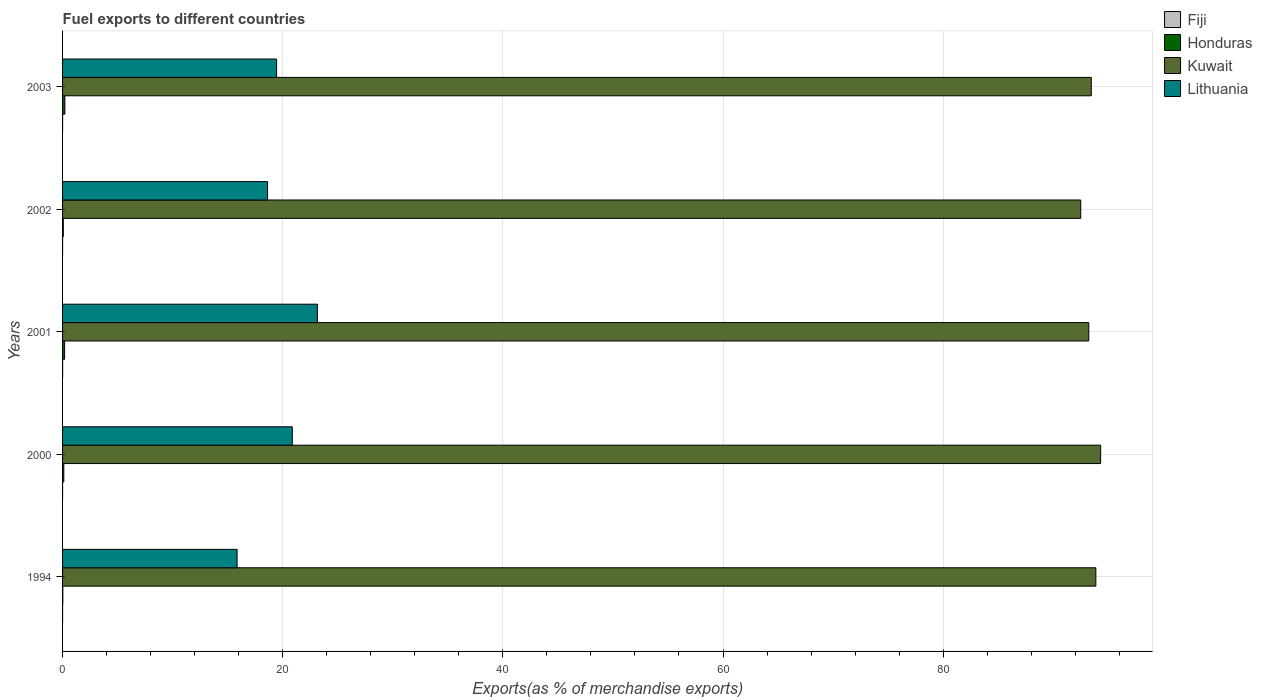How many different coloured bars are there?
Give a very brief answer. 4. Are the number of bars per tick equal to the number of legend labels?
Provide a succinct answer. Yes. Are the number of bars on each tick of the Y-axis equal?
Provide a succinct answer. Yes. How many bars are there on the 5th tick from the top?
Offer a terse response. 4. What is the percentage of exports to different countries in Kuwait in 2003?
Ensure brevity in your answer.  93.46. Across all years, what is the maximum percentage of exports to different countries in Honduras?
Keep it short and to the point. 0.21. Across all years, what is the minimum percentage of exports to different countries in Honduras?
Your answer should be compact. 0.02. In which year was the percentage of exports to different countries in Lithuania maximum?
Provide a succinct answer. 2001. In which year was the percentage of exports to different countries in Honduras minimum?
Provide a succinct answer. 1994. What is the total percentage of exports to different countries in Kuwait in the graph?
Ensure brevity in your answer.  467.36. What is the difference between the percentage of exports to different countries in Lithuania in 1994 and that in 2003?
Give a very brief answer. -3.59. What is the difference between the percentage of exports to different countries in Lithuania in 2001 and the percentage of exports to different countries in Kuwait in 2002?
Your answer should be very brief. -69.35. What is the average percentage of exports to different countries in Honduras per year?
Provide a short and direct response. 0.12. In the year 2001, what is the difference between the percentage of exports to different countries in Fiji and percentage of exports to different countries in Honduras?
Make the answer very short. -0.18. What is the ratio of the percentage of exports to different countries in Fiji in 2002 to that in 2003?
Your answer should be very brief. 1.53. Is the percentage of exports to different countries in Honduras in 2000 less than that in 2001?
Offer a very short reply. Yes. What is the difference between the highest and the second highest percentage of exports to different countries in Kuwait?
Your answer should be very brief. 0.43. What is the difference between the highest and the lowest percentage of exports to different countries in Fiji?
Offer a very short reply. 0.01. What does the 4th bar from the top in 2002 represents?
Your response must be concise. Fiji. What does the 2nd bar from the bottom in 1994 represents?
Provide a succinct answer. Honduras. Are all the bars in the graph horizontal?
Your answer should be very brief. Yes. What is the difference between two consecutive major ticks on the X-axis?
Your answer should be compact. 20. Does the graph contain any zero values?
Ensure brevity in your answer.  No. Where does the legend appear in the graph?
Ensure brevity in your answer.  Top right. How are the legend labels stacked?
Ensure brevity in your answer.  Vertical. What is the title of the graph?
Your answer should be compact. Fuel exports to different countries. Does "Jordan" appear as one of the legend labels in the graph?
Make the answer very short. No. What is the label or title of the X-axis?
Your answer should be very brief. Exports(as % of merchandise exports). What is the label or title of the Y-axis?
Provide a short and direct response. Years. What is the Exports(as % of merchandise exports) of Fiji in 1994?
Make the answer very short. 0. What is the Exports(as % of merchandise exports) in Honduras in 1994?
Ensure brevity in your answer.  0.02. What is the Exports(as % of merchandise exports) in Kuwait in 1994?
Make the answer very short. 93.87. What is the Exports(as % of merchandise exports) of Lithuania in 1994?
Offer a terse response. 15.86. What is the Exports(as % of merchandise exports) in Fiji in 2000?
Make the answer very short. 0. What is the Exports(as % of merchandise exports) in Honduras in 2000?
Keep it short and to the point. 0.11. What is the Exports(as % of merchandise exports) of Kuwait in 2000?
Ensure brevity in your answer.  94.31. What is the Exports(as % of merchandise exports) in Lithuania in 2000?
Keep it short and to the point. 20.87. What is the Exports(as % of merchandise exports) in Fiji in 2001?
Your response must be concise. 0.01. What is the Exports(as % of merchandise exports) of Honduras in 2001?
Your response must be concise. 0.18. What is the Exports(as % of merchandise exports) in Kuwait in 2001?
Offer a terse response. 93.23. What is the Exports(as % of merchandise exports) of Lithuania in 2001?
Offer a very short reply. 23.15. What is the Exports(as % of merchandise exports) of Fiji in 2002?
Give a very brief answer. 0. What is the Exports(as % of merchandise exports) in Honduras in 2002?
Provide a short and direct response. 0.07. What is the Exports(as % of merchandise exports) of Kuwait in 2002?
Provide a succinct answer. 92.5. What is the Exports(as % of merchandise exports) in Lithuania in 2002?
Your response must be concise. 18.62. What is the Exports(as % of merchandise exports) of Fiji in 2003?
Give a very brief answer. 0. What is the Exports(as % of merchandise exports) in Honduras in 2003?
Give a very brief answer. 0.21. What is the Exports(as % of merchandise exports) of Kuwait in 2003?
Ensure brevity in your answer.  93.46. What is the Exports(as % of merchandise exports) of Lithuania in 2003?
Make the answer very short. 19.44. Across all years, what is the maximum Exports(as % of merchandise exports) in Fiji?
Provide a succinct answer. 0.01. Across all years, what is the maximum Exports(as % of merchandise exports) in Honduras?
Your answer should be very brief. 0.21. Across all years, what is the maximum Exports(as % of merchandise exports) of Kuwait?
Ensure brevity in your answer.  94.31. Across all years, what is the maximum Exports(as % of merchandise exports) in Lithuania?
Offer a very short reply. 23.15. Across all years, what is the minimum Exports(as % of merchandise exports) of Fiji?
Give a very brief answer. 0. Across all years, what is the minimum Exports(as % of merchandise exports) of Honduras?
Offer a terse response. 0.02. Across all years, what is the minimum Exports(as % of merchandise exports) in Kuwait?
Give a very brief answer. 92.5. Across all years, what is the minimum Exports(as % of merchandise exports) in Lithuania?
Make the answer very short. 15.86. What is the total Exports(as % of merchandise exports) of Fiji in the graph?
Offer a very short reply. 0.01. What is the total Exports(as % of merchandise exports) in Honduras in the graph?
Make the answer very short. 0.6. What is the total Exports(as % of merchandise exports) of Kuwait in the graph?
Your response must be concise. 467.36. What is the total Exports(as % of merchandise exports) of Lithuania in the graph?
Ensure brevity in your answer.  97.95. What is the difference between the Exports(as % of merchandise exports) in Fiji in 1994 and that in 2000?
Offer a very short reply. 0. What is the difference between the Exports(as % of merchandise exports) of Honduras in 1994 and that in 2000?
Keep it short and to the point. -0.09. What is the difference between the Exports(as % of merchandise exports) in Kuwait in 1994 and that in 2000?
Ensure brevity in your answer.  -0.43. What is the difference between the Exports(as % of merchandise exports) of Lithuania in 1994 and that in 2000?
Your answer should be very brief. -5.02. What is the difference between the Exports(as % of merchandise exports) in Fiji in 1994 and that in 2001?
Offer a very short reply. -0. What is the difference between the Exports(as % of merchandise exports) of Honduras in 1994 and that in 2001?
Your answer should be compact. -0.16. What is the difference between the Exports(as % of merchandise exports) in Kuwait in 1994 and that in 2001?
Make the answer very short. 0.64. What is the difference between the Exports(as % of merchandise exports) of Lithuania in 1994 and that in 2001?
Your answer should be very brief. -7.3. What is the difference between the Exports(as % of merchandise exports) in Fiji in 1994 and that in 2002?
Your answer should be compact. 0. What is the difference between the Exports(as % of merchandise exports) in Honduras in 1994 and that in 2002?
Keep it short and to the point. -0.05. What is the difference between the Exports(as % of merchandise exports) in Kuwait in 1994 and that in 2002?
Your answer should be compact. 1.37. What is the difference between the Exports(as % of merchandise exports) in Lithuania in 1994 and that in 2002?
Your response must be concise. -2.77. What is the difference between the Exports(as % of merchandise exports) of Fiji in 1994 and that in 2003?
Your answer should be very brief. 0. What is the difference between the Exports(as % of merchandise exports) in Honduras in 1994 and that in 2003?
Provide a short and direct response. -0.19. What is the difference between the Exports(as % of merchandise exports) in Kuwait in 1994 and that in 2003?
Your answer should be very brief. 0.41. What is the difference between the Exports(as % of merchandise exports) in Lithuania in 1994 and that in 2003?
Provide a short and direct response. -3.59. What is the difference between the Exports(as % of merchandise exports) of Fiji in 2000 and that in 2001?
Provide a succinct answer. -0.01. What is the difference between the Exports(as % of merchandise exports) of Honduras in 2000 and that in 2001?
Provide a succinct answer. -0.07. What is the difference between the Exports(as % of merchandise exports) in Kuwait in 2000 and that in 2001?
Your answer should be very brief. 1.08. What is the difference between the Exports(as % of merchandise exports) of Lithuania in 2000 and that in 2001?
Make the answer very short. -2.28. What is the difference between the Exports(as % of merchandise exports) in Fiji in 2000 and that in 2002?
Offer a terse response. -0. What is the difference between the Exports(as % of merchandise exports) in Honduras in 2000 and that in 2002?
Offer a very short reply. 0.05. What is the difference between the Exports(as % of merchandise exports) in Kuwait in 2000 and that in 2002?
Ensure brevity in your answer.  1.81. What is the difference between the Exports(as % of merchandise exports) in Lithuania in 2000 and that in 2002?
Your response must be concise. 2.25. What is the difference between the Exports(as % of merchandise exports) of Fiji in 2000 and that in 2003?
Your response must be concise. -0. What is the difference between the Exports(as % of merchandise exports) in Honduras in 2000 and that in 2003?
Make the answer very short. -0.1. What is the difference between the Exports(as % of merchandise exports) of Kuwait in 2000 and that in 2003?
Your response must be concise. 0.85. What is the difference between the Exports(as % of merchandise exports) in Lithuania in 2000 and that in 2003?
Provide a succinct answer. 1.43. What is the difference between the Exports(as % of merchandise exports) of Fiji in 2001 and that in 2002?
Provide a short and direct response. 0.01. What is the difference between the Exports(as % of merchandise exports) of Honduras in 2001 and that in 2002?
Give a very brief answer. 0.12. What is the difference between the Exports(as % of merchandise exports) in Kuwait in 2001 and that in 2002?
Your answer should be very brief. 0.73. What is the difference between the Exports(as % of merchandise exports) of Lithuania in 2001 and that in 2002?
Offer a very short reply. 4.53. What is the difference between the Exports(as % of merchandise exports) of Fiji in 2001 and that in 2003?
Your answer should be compact. 0.01. What is the difference between the Exports(as % of merchandise exports) of Honduras in 2001 and that in 2003?
Offer a terse response. -0.03. What is the difference between the Exports(as % of merchandise exports) in Kuwait in 2001 and that in 2003?
Give a very brief answer. -0.23. What is the difference between the Exports(as % of merchandise exports) of Lithuania in 2001 and that in 2003?
Keep it short and to the point. 3.71. What is the difference between the Exports(as % of merchandise exports) in Honduras in 2002 and that in 2003?
Your answer should be compact. -0.14. What is the difference between the Exports(as % of merchandise exports) of Kuwait in 2002 and that in 2003?
Keep it short and to the point. -0.96. What is the difference between the Exports(as % of merchandise exports) in Lithuania in 2002 and that in 2003?
Provide a short and direct response. -0.82. What is the difference between the Exports(as % of merchandise exports) of Fiji in 1994 and the Exports(as % of merchandise exports) of Honduras in 2000?
Give a very brief answer. -0.11. What is the difference between the Exports(as % of merchandise exports) in Fiji in 1994 and the Exports(as % of merchandise exports) in Kuwait in 2000?
Give a very brief answer. -94.3. What is the difference between the Exports(as % of merchandise exports) in Fiji in 1994 and the Exports(as % of merchandise exports) in Lithuania in 2000?
Give a very brief answer. -20.87. What is the difference between the Exports(as % of merchandise exports) in Honduras in 1994 and the Exports(as % of merchandise exports) in Kuwait in 2000?
Provide a succinct answer. -94.28. What is the difference between the Exports(as % of merchandise exports) in Honduras in 1994 and the Exports(as % of merchandise exports) in Lithuania in 2000?
Provide a short and direct response. -20.85. What is the difference between the Exports(as % of merchandise exports) in Kuwait in 1994 and the Exports(as % of merchandise exports) in Lithuania in 2000?
Offer a terse response. 73. What is the difference between the Exports(as % of merchandise exports) of Fiji in 1994 and the Exports(as % of merchandise exports) of Honduras in 2001?
Provide a succinct answer. -0.18. What is the difference between the Exports(as % of merchandise exports) of Fiji in 1994 and the Exports(as % of merchandise exports) of Kuwait in 2001?
Your answer should be very brief. -93.23. What is the difference between the Exports(as % of merchandise exports) of Fiji in 1994 and the Exports(as % of merchandise exports) of Lithuania in 2001?
Your response must be concise. -23.15. What is the difference between the Exports(as % of merchandise exports) in Honduras in 1994 and the Exports(as % of merchandise exports) in Kuwait in 2001?
Provide a short and direct response. -93.21. What is the difference between the Exports(as % of merchandise exports) of Honduras in 1994 and the Exports(as % of merchandise exports) of Lithuania in 2001?
Your answer should be very brief. -23.13. What is the difference between the Exports(as % of merchandise exports) in Kuwait in 1994 and the Exports(as % of merchandise exports) in Lithuania in 2001?
Your answer should be compact. 70.72. What is the difference between the Exports(as % of merchandise exports) of Fiji in 1994 and the Exports(as % of merchandise exports) of Honduras in 2002?
Provide a succinct answer. -0.07. What is the difference between the Exports(as % of merchandise exports) in Fiji in 1994 and the Exports(as % of merchandise exports) in Kuwait in 2002?
Make the answer very short. -92.5. What is the difference between the Exports(as % of merchandise exports) in Fiji in 1994 and the Exports(as % of merchandise exports) in Lithuania in 2002?
Provide a succinct answer. -18.62. What is the difference between the Exports(as % of merchandise exports) of Honduras in 1994 and the Exports(as % of merchandise exports) of Kuwait in 2002?
Provide a succinct answer. -92.48. What is the difference between the Exports(as % of merchandise exports) in Honduras in 1994 and the Exports(as % of merchandise exports) in Lithuania in 2002?
Provide a succinct answer. -18.6. What is the difference between the Exports(as % of merchandise exports) in Kuwait in 1994 and the Exports(as % of merchandise exports) in Lithuania in 2002?
Your answer should be very brief. 75.25. What is the difference between the Exports(as % of merchandise exports) in Fiji in 1994 and the Exports(as % of merchandise exports) in Honduras in 2003?
Provide a succinct answer. -0.21. What is the difference between the Exports(as % of merchandise exports) in Fiji in 1994 and the Exports(as % of merchandise exports) in Kuwait in 2003?
Ensure brevity in your answer.  -93.46. What is the difference between the Exports(as % of merchandise exports) of Fiji in 1994 and the Exports(as % of merchandise exports) of Lithuania in 2003?
Make the answer very short. -19.44. What is the difference between the Exports(as % of merchandise exports) of Honduras in 1994 and the Exports(as % of merchandise exports) of Kuwait in 2003?
Provide a succinct answer. -93.43. What is the difference between the Exports(as % of merchandise exports) of Honduras in 1994 and the Exports(as % of merchandise exports) of Lithuania in 2003?
Your answer should be very brief. -19.42. What is the difference between the Exports(as % of merchandise exports) in Kuwait in 1994 and the Exports(as % of merchandise exports) in Lithuania in 2003?
Keep it short and to the point. 74.43. What is the difference between the Exports(as % of merchandise exports) of Fiji in 2000 and the Exports(as % of merchandise exports) of Honduras in 2001?
Provide a succinct answer. -0.18. What is the difference between the Exports(as % of merchandise exports) in Fiji in 2000 and the Exports(as % of merchandise exports) in Kuwait in 2001?
Provide a short and direct response. -93.23. What is the difference between the Exports(as % of merchandise exports) in Fiji in 2000 and the Exports(as % of merchandise exports) in Lithuania in 2001?
Your response must be concise. -23.15. What is the difference between the Exports(as % of merchandise exports) of Honduras in 2000 and the Exports(as % of merchandise exports) of Kuwait in 2001?
Ensure brevity in your answer.  -93.12. What is the difference between the Exports(as % of merchandise exports) in Honduras in 2000 and the Exports(as % of merchandise exports) in Lithuania in 2001?
Ensure brevity in your answer.  -23.04. What is the difference between the Exports(as % of merchandise exports) of Kuwait in 2000 and the Exports(as % of merchandise exports) of Lithuania in 2001?
Provide a short and direct response. 71.15. What is the difference between the Exports(as % of merchandise exports) in Fiji in 2000 and the Exports(as % of merchandise exports) in Honduras in 2002?
Offer a very short reply. -0.07. What is the difference between the Exports(as % of merchandise exports) in Fiji in 2000 and the Exports(as % of merchandise exports) in Kuwait in 2002?
Offer a very short reply. -92.5. What is the difference between the Exports(as % of merchandise exports) of Fiji in 2000 and the Exports(as % of merchandise exports) of Lithuania in 2002?
Ensure brevity in your answer.  -18.62. What is the difference between the Exports(as % of merchandise exports) of Honduras in 2000 and the Exports(as % of merchandise exports) of Kuwait in 2002?
Your answer should be very brief. -92.39. What is the difference between the Exports(as % of merchandise exports) in Honduras in 2000 and the Exports(as % of merchandise exports) in Lithuania in 2002?
Provide a short and direct response. -18.51. What is the difference between the Exports(as % of merchandise exports) of Kuwait in 2000 and the Exports(as % of merchandise exports) of Lithuania in 2002?
Your answer should be very brief. 75.68. What is the difference between the Exports(as % of merchandise exports) of Fiji in 2000 and the Exports(as % of merchandise exports) of Honduras in 2003?
Keep it short and to the point. -0.21. What is the difference between the Exports(as % of merchandise exports) in Fiji in 2000 and the Exports(as % of merchandise exports) in Kuwait in 2003?
Your answer should be very brief. -93.46. What is the difference between the Exports(as % of merchandise exports) in Fiji in 2000 and the Exports(as % of merchandise exports) in Lithuania in 2003?
Your response must be concise. -19.44. What is the difference between the Exports(as % of merchandise exports) in Honduras in 2000 and the Exports(as % of merchandise exports) in Kuwait in 2003?
Provide a succinct answer. -93.34. What is the difference between the Exports(as % of merchandise exports) in Honduras in 2000 and the Exports(as % of merchandise exports) in Lithuania in 2003?
Keep it short and to the point. -19.33. What is the difference between the Exports(as % of merchandise exports) of Kuwait in 2000 and the Exports(as % of merchandise exports) of Lithuania in 2003?
Provide a succinct answer. 74.86. What is the difference between the Exports(as % of merchandise exports) of Fiji in 2001 and the Exports(as % of merchandise exports) of Honduras in 2002?
Provide a succinct answer. -0.06. What is the difference between the Exports(as % of merchandise exports) in Fiji in 2001 and the Exports(as % of merchandise exports) in Kuwait in 2002?
Offer a terse response. -92.49. What is the difference between the Exports(as % of merchandise exports) in Fiji in 2001 and the Exports(as % of merchandise exports) in Lithuania in 2002?
Offer a very short reply. -18.62. What is the difference between the Exports(as % of merchandise exports) of Honduras in 2001 and the Exports(as % of merchandise exports) of Kuwait in 2002?
Your answer should be compact. -92.31. What is the difference between the Exports(as % of merchandise exports) in Honduras in 2001 and the Exports(as % of merchandise exports) in Lithuania in 2002?
Offer a very short reply. -18.44. What is the difference between the Exports(as % of merchandise exports) of Kuwait in 2001 and the Exports(as % of merchandise exports) of Lithuania in 2002?
Provide a short and direct response. 74.61. What is the difference between the Exports(as % of merchandise exports) in Fiji in 2001 and the Exports(as % of merchandise exports) in Honduras in 2003?
Ensure brevity in your answer.  -0.2. What is the difference between the Exports(as % of merchandise exports) in Fiji in 2001 and the Exports(as % of merchandise exports) in Kuwait in 2003?
Offer a terse response. -93.45. What is the difference between the Exports(as % of merchandise exports) of Fiji in 2001 and the Exports(as % of merchandise exports) of Lithuania in 2003?
Offer a terse response. -19.44. What is the difference between the Exports(as % of merchandise exports) in Honduras in 2001 and the Exports(as % of merchandise exports) in Kuwait in 2003?
Your response must be concise. -93.27. What is the difference between the Exports(as % of merchandise exports) in Honduras in 2001 and the Exports(as % of merchandise exports) in Lithuania in 2003?
Your response must be concise. -19.26. What is the difference between the Exports(as % of merchandise exports) in Kuwait in 2001 and the Exports(as % of merchandise exports) in Lithuania in 2003?
Give a very brief answer. 73.79. What is the difference between the Exports(as % of merchandise exports) in Fiji in 2002 and the Exports(as % of merchandise exports) in Honduras in 2003?
Make the answer very short. -0.21. What is the difference between the Exports(as % of merchandise exports) of Fiji in 2002 and the Exports(as % of merchandise exports) of Kuwait in 2003?
Your response must be concise. -93.46. What is the difference between the Exports(as % of merchandise exports) in Fiji in 2002 and the Exports(as % of merchandise exports) in Lithuania in 2003?
Your answer should be compact. -19.44. What is the difference between the Exports(as % of merchandise exports) of Honduras in 2002 and the Exports(as % of merchandise exports) of Kuwait in 2003?
Your answer should be compact. -93.39. What is the difference between the Exports(as % of merchandise exports) in Honduras in 2002 and the Exports(as % of merchandise exports) in Lithuania in 2003?
Give a very brief answer. -19.38. What is the difference between the Exports(as % of merchandise exports) in Kuwait in 2002 and the Exports(as % of merchandise exports) in Lithuania in 2003?
Your response must be concise. 73.05. What is the average Exports(as % of merchandise exports) in Fiji per year?
Provide a short and direct response. 0. What is the average Exports(as % of merchandise exports) in Honduras per year?
Ensure brevity in your answer.  0.12. What is the average Exports(as % of merchandise exports) of Kuwait per year?
Keep it short and to the point. 93.47. What is the average Exports(as % of merchandise exports) of Lithuania per year?
Ensure brevity in your answer.  19.59. In the year 1994, what is the difference between the Exports(as % of merchandise exports) in Fiji and Exports(as % of merchandise exports) in Honduras?
Keep it short and to the point. -0.02. In the year 1994, what is the difference between the Exports(as % of merchandise exports) of Fiji and Exports(as % of merchandise exports) of Kuwait?
Give a very brief answer. -93.87. In the year 1994, what is the difference between the Exports(as % of merchandise exports) in Fiji and Exports(as % of merchandise exports) in Lithuania?
Ensure brevity in your answer.  -15.85. In the year 1994, what is the difference between the Exports(as % of merchandise exports) in Honduras and Exports(as % of merchandise exports) in Kuwait?
Your answer should be very brief. -93.85. In the year 1994, what is the difference between the Exports(as % of merchandise exports) in Honduras and Exports(as % of merchandise exports) in Lithuania?
Keep it short and to the point. -15.83. In the year 1994, what is the difference between the Exports(as % of merchandise exports) of Kuwait and Exports(as % of merchandise exports) of Lithuania?
Provide a short and direct response. 78.01. In the year 2000, what is the difference between the Exports(as % of merchandise exports) of Fiji and Exports(as % of merchandise exports) of Honduras?
Offer a very short reply. -0.11. In the year 2000, what is the difference between the Exports(as % of merchandise exports) of Fiji and Exports(as % of merchandise exports) of Kuwait?
Your response must be concise. -94.31. In the year 2000, what is the difference between the Exports(as % of merchandise exports) in Fiji and Exports(as % of merchandise exports) in Lithuania?
Your answer should be very brief. -20.87. In the year 2000, what is the difference between the Exports(as % of merchandise exports) of Honduras and Exports(as % of merchandise exports) of Kuwait?
Offer a very short reply. -94.19. In the year 2000, what is the difference between the Exports(as % of merchandise exports) in Honduras and Exports(as % of merchandise exports) in Lithuania?
Your answer should be very brief. -20.76. In the year 2000, what is the difference between the Exports(as % of merchandise exports) of Kuwait and Exports(as % of merchandise exports) of Lithuania?
Provide a short and direct response. 73.43. In the year 2001, what is the difference between the Exports(as % of merchandise exports) in Fiji and Exports(as % of merchandise exports) in Honduras?
Your answer should be very brief. -0.18. In the year 2001, what is the difference between the Exports(as % of merchandise exports) of Fiji and Exports(as % of merchandise exports) of Kuwait?
Provide a succinct answer. -93.22. In the year 2001, what is the difference between the Exports(as % of merchandise exports) in Fiji and Exports(as % of merchandise exports) in Lithuania?
Your response must be concise. -23.15. In the year 2001, what is the difference between the Exports(as % of merchandise exports) of Honduras and Exports(as % of merchandise exports) of Kuwait?
Provide a succinct answer. -93.05. In the year 2001, what is the difference between the Exports(as % of merchandise exports) of Honduras and Exports(as % of merchandise exports) of Lithuania?
Your answer should be compact. -22.97. In the year 2001, what is the difference between the Exports(as % of merchandise exports) in Kuwait and Exports(as % of merchandise exports) in Lithuania?
Keep it short and to the point. 70.08. In the year 2002, what is the difference between the Exports(as % of merchandise exports) in Fiji and Exports(as % of merchandise exports) in Honduras?
Your answer should be very brief. -0.07. In the year 2002, what is the difference between the Exports(as % of merchandise exports) of Fiji and Exports(as % of merchandise exports) of Kuwait?
Offer a very short reply. -92.5. In the year 2002, what is the difference between the Exports(as % of merchandise exports) in Fiji and Exports(as % of merchandise exports) in Lithuania?
Your response must be concise. -18.62. In the year 2002, what is the difference between the Exports(as % of merchandise exports) of Honduras and Exports(as % of merchandise exports) of Kuwait?
Provide a short and direct response. -92.43. In the year 2002, what is the difference between the Exports(as % of merchandise exports) in Honduras and Exports(as % of merchandise exports) in Lithuania?
Keep it short and to the point. -18.56. In the year 2002, what is the difference between the Exports(as % of merchandise exports) in Kuwait and Exports(as % of merchandise exports) in Lithuania?
Offer a terse response. 73.87. In the year 2003, what is the difference between the Exports(as % of merchandise exports) of Fiji and Exports(as % of merchandise exports) of Honduras?
Ensure brevity in your answer.  -0.21. In the year 2003, what is the difference between the Exports(as % of merchandise exports) of Fiji and Exports(as % of merchandise exports) of Kuwait?
Give a very brief answer. -93.46. In the year 2003, what is the difference between the Exports(as % of merchandise exports) of Fiji and Exports(as % of merchandise exports) of Lithuania?
Keep it short and to the point. -19.44. In the year 2003, what is the difference between the Exports(as % of merchandise exports) of Honduras and Exports(as % of merchandise exports) of Kuwait?
Make the answer very short. -93.25. In the year 2003, what is the difference between the Exports(as % of merchandise exports) of Honduras and Exports(as % of merchandise exports) of Lithuania?
Offer a very short reply. -19.23. In the year 2003, what is the difference between the Exports(as % of merchandise exports) of Kuwait and Exports(as % of merchandise exports) of Lithuania?
Your response must be concise. 74.01. What is the ratio of the Exports(as % of merchandise exports) in Fiji in 1994 to that in 2000?
Your answer should be very brief. 5.01. What is the ratio of the Exports(as % of merchandise exports) in Honduras in 1994 to that in 2000?
Provide a short and direct response. 0.19. What is the ratio of the Exports(as % of merchandise exports) of Kuwait in 1994 to that in 2000?
Ensure brevity in your answer.  1. What is the ratio of the Exports(as % of merchandise exports) of Lithuania in 1994 to that in 2000?
Offer a very short reply. 0.76. What is the ratio of the Exports(as % of merchandise exports) in Fiji in 1994 to that in 2001?
Ensure brevity in your answer.  0.22. What is the ratio of the Exports(as % of merchandise exports) of Honduras in 1994 to that in 2001?
Your answer should be compact. 0.12. What is the ratio of the Exports(as % of merchandise exports) in Lithuania in 1994 to that in 2001?
Offer a very short reply. 0.68. What is the ratio of the Exports(as % of merchandise exports) of Fiji in 1994 to that in 2002?
Make the answer very short. 1.89. What is the ratio of the Exports(as % of merchandise exports) of Honduras in 1994 to that in 2002?
Ensure brevity in your answer.  0.33. What is the ratio of the Exports(as % of merchandise exports) of Kuwait in 1994 to that in 2002?
Your answer should be very brief. 1.01. What is the ratio of the Exports(as % of merchandise exports) in Lithuania in 1994 to that in 2002?
Ensure brevity in your answer.  0.85. What is the ratio of the Exports(as % of merchandise exports) of Fiji in 1994 to that in 2003?
Your response must be concise. 2.88. What is the ratio of the Exports(as % of merchandise exports) in Honduras in 1994 to that in 2003?
Your response must be concise. 0.1. What is the ratio of the Exports(as % of merchandise exports) of Kuwait in 1994 to that in 2003?
Give a very brief answer. 1. What is the ratio of the Exports(as % of merchandise exports) in Lithuania in 1994 to that in 2003?
Give a very brief answer. 0.82. What is the ratio of the Exports(as % of merchandise exports) in Fiji in 2000 to that in 2001?
Ensure brevity in your answer.  0.04. What is the ratio of the Exports(as % of merchandise exports) of Honduras in 2000 to that in 2001?
Your answer should be compact. 0.61. What is the ratio of the Exports(as % of merchandise exports) in Kuwait in 2000 to that in 2001?
Offer a very short reply. 1.01. What is the ratio of the Exports(as % of merchandise exports) of Lithuania in 2000 to that in 2001?
Provide a succinct answer. 0.9. What is the ratio of the Exports(as % of merchandise exports) of Fiji in 2000 to that in 2002?
Your answer should be compact. 0.38. What is the ratio of the Exports(as % of merchandise exports) of Honduras in 2000 to that in 2002?
Ensure brevity in your answer.  1.7. What is the ratio of the Exports(as % of merchandise exports) in Kuwait in 2000 to that in 2002?
Your answer should be compact. 1.02. What is the ratio of the Exports(as % of merchandise exports) of Lithuania in 2000 to that in 2002?
Your answer should be compact. 1.12. What is the ratio of the Exports(as % of merchandise exports) of Fiji in 2000 to that in 2003?
Provide a short and direct response. 0.57. What is the ratio of the Exports(as % of merchandise exports) in Honduras in 2000 to that in 2003?
Offer a very short reply. 0.54. What is the ratio of the Exports(as % of merchandise exports) in Kuwait in 2000 to that in 2003?
Provide a succinct answer. 1.01. What is the ratio of the Exports(as % of merchandise exports) in Lithuania in 2000 to that in 2003?
Provide a short and direct response. 1.07. What is the ratio of the Exports(as % of merchandise exports) of Fiji in 2001 to that in 2002?
Your answer should be very brief. 8.51. What is the ratio of the Exports(as % of merchandise exports) in Honduras in 2001 to that in 2002?
Provide a succinct answer. 2.77. What is the ratio of the Exports(as % of merchandise exports) of Kuwait in 2001 to that in 2002?
Give a very brief answer. 1.01. What is the ratio of the Exports(as % of merchandise exports) of Lithuania in 2001 to that in 2002?
Keep it short and to the point. 1.24. What is the ratio of the Exports(as % of merchandise exports) in Fiji in 2001 to that in 2003?
Provide a short and direct response. 12.98. What is the ratio of the Exports(as % of merchandise exports) in Honduras in 2001 to that in 2003?
Your answer should be compact. 0.88. What is the ratio of the Exports(as % of merchandise exports) of Lithuania in 2001 to that in 2003?
Ensure brevity in your answer.  1.19. What is the ratio of the Exports(as % of merchandise exports) of Fiji in 2002 to that in 2003?
Your answer should be very brief. 1.53. What is the ratio of the Exports(as % of merchandise exports) in Honduras in 2002 to that in 2003?
Provide a short and direct response. 0.32. What is the ratio of the Exports(as % of merchandise exports) of Kuwait in 2002 to that in 2003?
Your answer should be compact. 0.99. What is the ratio of the Exports(as % of merchandise exports) in Lithuania in 2002 to that in 2003?
Your answer should be very brief. 0.96. What is the difference between the highest and the second highest Exports(as % of merchandise exports) in Fiji?
Your response must be concise. 0. What is the difference between the highest and the second highest Exports(as % of merchandise exports) of Honduras?
Keep it short and to the point. 0.03. What is the difference between the highest and the second highest Exports(as % of merchandise exports) of Kuwait?
Your response must be concise. 0.43. What is the difference between the highest and the second highest Exports(as % of merchandise exports) of Lithuania?
Make the answer very short. 2.28. What is the difference between the highest and the lowest Exports(as % of merchandise exports) in Fiji?
Offer a very short reply. 0.01. What is the difference between the highest and the lowest Exports(as % of merchandise exports) of Honduras?
Give a very brief answer. 0.19. What is the difference between the highest and the lowest Exports(as % of merchandise exports) of Kuwait?
Provide a succinct answer. 1.81. What is the difference between the highest and the lowest Exports(as % of merchandise exports) in Lithuania?
Your response must be concise. 7.3. 